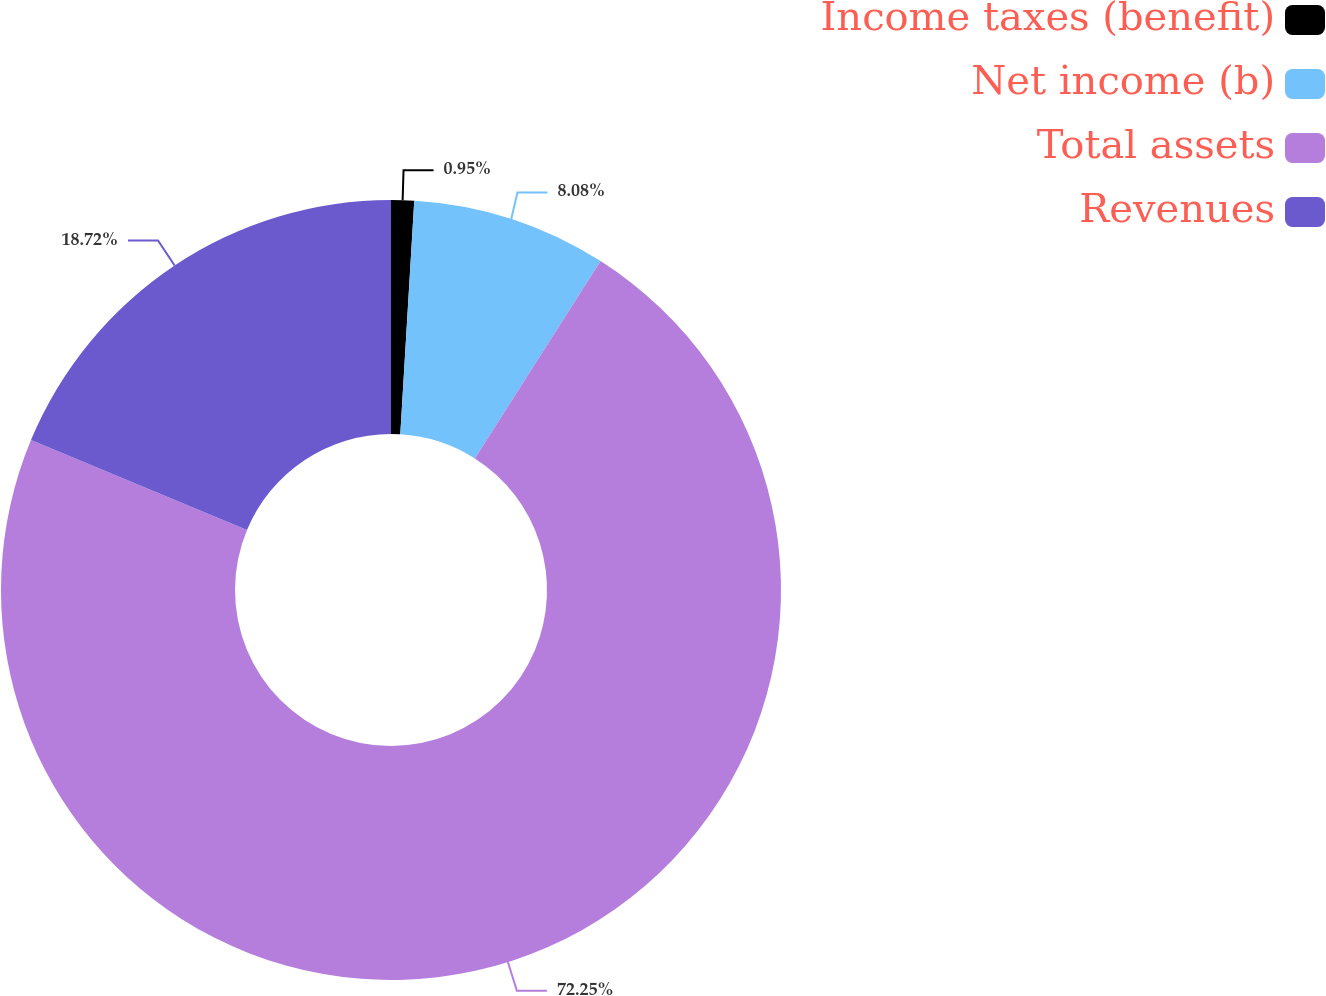Convert chart. <chart><loc_0><loc_0><loc_500><loc_500><pie_chart><fcel>Income taxes (benefit)<fcel>Net income (b)<fcel>Total assets<fcel>Revenues<nl><fcel>0.95%<fcel>8.08%<fcel>72.25%<fcel>18.72%<nl></chart> 